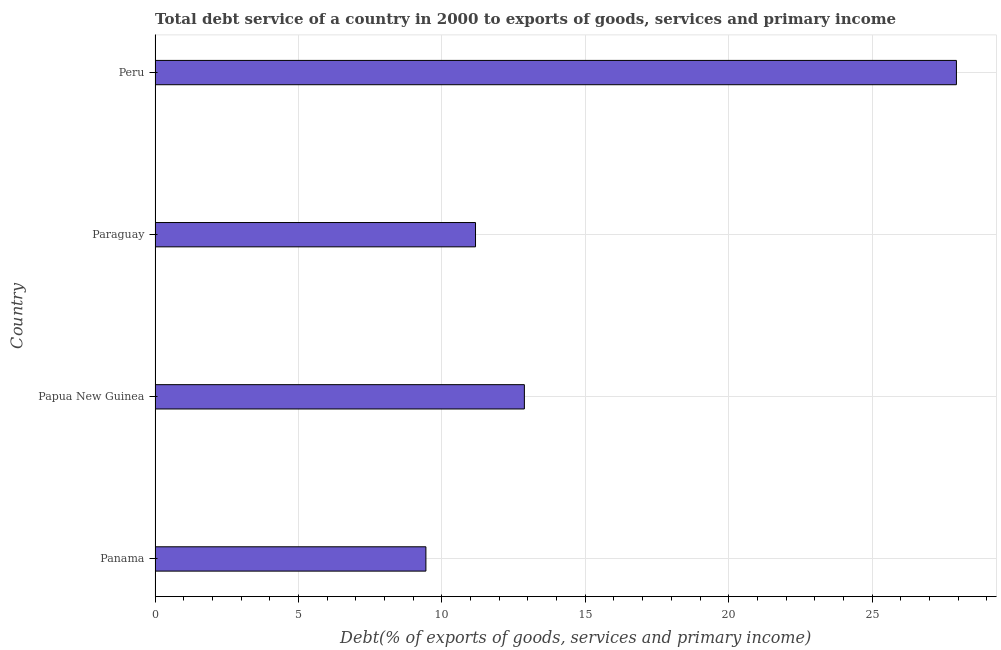Does the graph contain any zero values?
Your answer should be very brief. No. What is the title of the graph?
Provide a succinct answer. Total debt service of a country in 2000 to exports of goods, services and primary income. What is the label or title of the X-axis?
Give a very brief answer. Debt(% of exports of goods, services and primary income). What is the label or title of the Y-axis?
Offer a very short reply. Country. What is the total debt service in Panama?
Make the answer very short. 9.44. Across all countries, what is the maximum total debt service?
Your answer should be very brief. 27.94. Across all countries, what is the minimum total debt service?
Provide a short and direct response. 9.44. In which country was the total debt service minimum?
Offer a very short reply. Panama. What is the sum of the total debt service?
Offer a very short reply. 61.43. What is the difference between the total debt service in Papua New Guinea and Paraguay?
Offer a very short reply. 1.7. What is the average total debt service per country?
Provide a short and direct response. 15.36. What is the median total debt service?
Provide a short and direct response. 12.02. In how many countries, is the total debt service greater than 6 %?
Your response must be concise. 4. What is the ratio of the total debt service in Panama to that in Papua New Guinea?
Offer a terse response. 0.73. Is the total debt service in Paraguay less than that in Peru?
Provide a succinct answer. Yes. What is the difference between the highest and the second highest total debt service?
Give a very brief answer. 15.06. What is the difference between the highest and the lowest total debt service?
Your response must be concise. 18.5. In how many countries, is the total debt service greater than the average total debt service taken over all countries?
Ensure brevity in your answer.  1. Are all the bars in the graph horizontal?
Give a very brief answer. Yes. What is the difference between two consecutive major ticks on the X-axis?
Provide a short and direct response. 5. What is the Debt(% of exports of goods, services and primary income) in Panama?
Offer a very short reply. 9.44. What is the Debt(% of exports of goods, services and primary income) of Papua New Guinea?
Keep it short and to the point. 12.88. What is the Debt(% of exports of goods, services and primary income) of Paraguay?
Provide a short and direct response. 11.17. What is the Debt(% of exports of goods, services and primary income) in Peru?
Offer a very short reply. 27.94. What is the difference between the Debt(% of exports of goods, services and primary income) in Panama and Papua New Guinea?
Your response must be concise. -3.43. What is the difference between the Debt(% of exports of goods, services and primary income) in Panama and Paraguay?
Provide a succinct answer. -1.73. What is the difference between the Debt(% of exports of goods, services and primary income) in Panama and Peru?
Give a very brief answer. -18.5. What is the difference between the Debt(% of exports of goods, services and primary income) in Papua New Guinea and Paraguay?
Provide a succinct answer. 1.7. What is the difference between the Debt(% of exports of goods, services and primary income) in Papua New Guinea and Peru?
Your answer should be very brief. -15.06. What is the difference between the Debt(% of exports of goods, services and primary income) in Paraguay and Peru?
Make the answer very short. -16.77. What is the ratio of the Debt(% of exports of goods, services and primary income) in Panama to that in Papua New Guinea?
Offer a very short reply. 0.73. What is the ratio of the Debt(% of exports of goods, services and primary income) in Panama to that in Paraguay?
Your answer should be compact. 0.84. What is the ratio of the Debt(% of exports of goods, services and primary income) in Panama to that in Peru?
Give a very brief answer. 0.34. What is the ratio of the Debt(% of exports of goods, services and primary income) in Papua New Guinea to that in Paraguay?
Offer a terse response. 1.15. What is the ratio of the Debt(% of exports of goods, services and primary income) in Papua New Guinea to that in Peru?
Give a very brief answer. 0.46. What is the ratio of the Debt(% of exports of goods, services and primary income) in Paraguay to that in Peru?
Provide a succinct answer. 0.4. 